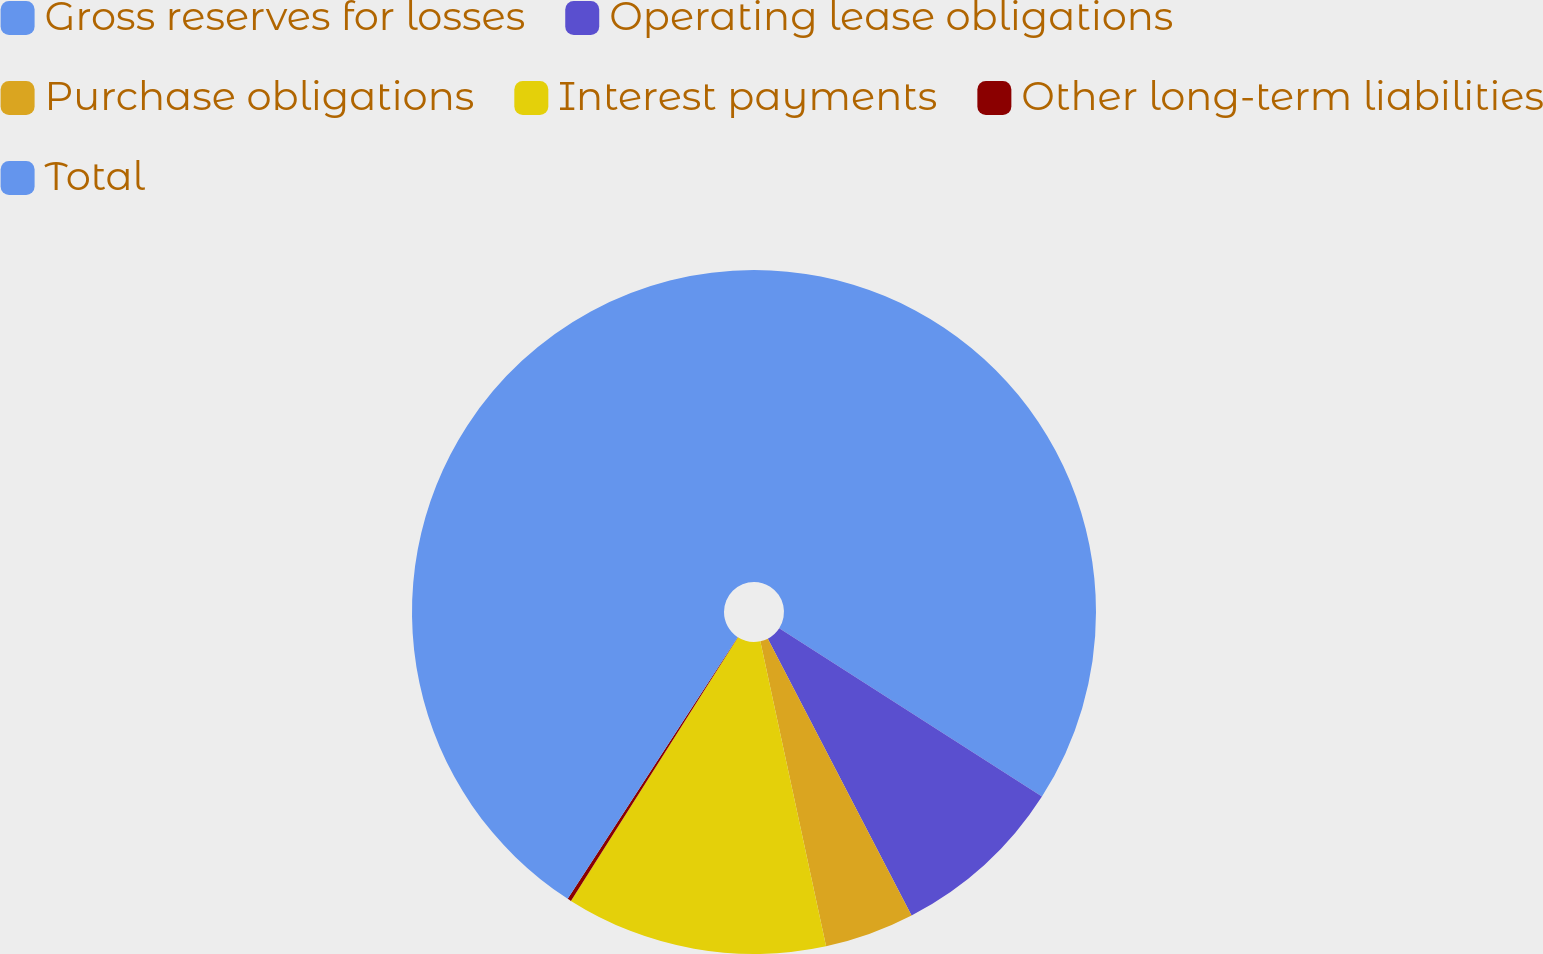<chart> <loc_0><loc_0><loc_500><loc_500><pie_chart><fcel>Gross reserves for losses<fcel>Operating lease obligations<fcel>Purchase obligations<fcel>Interest payments<fcel>Other long-term liabilities<fcel>Total<nl><fcel>34.07%<fcel>8.31%<fcel>4.24%<fcel>12.37%<fcel>0.18%<fcel>40.83%<nl></chart> 